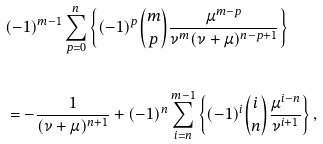<formula> <loc_0><loc_0><loc_500><loc_500>& ( - 1 ) ^ { m - 1 } \sum _ { p = 0 } ^ { n } { \left \{ { ( - 1 ) ^ { p } \binom { m } { p } \frac { { \mu ^ { m - p } } } { { \nu ^ { m } ( \nu + \mu ) ^ { n - p + 1 } } } } \right \} } \\ & \\ & = - \frac { 1 } { { ( \nu + \mu ) ^ { n + 1 } } } + ( - 1 ) ^ { n } \sum _ { i = n } ^ { m - 1 } { \left \{ { ( - 1 ) ^ { i } \binom { i } { n } \frac { { \mu ^ { i - n } } } { { \nu ^ { i + 1 } } } } \right \} } \, ,</formula> 